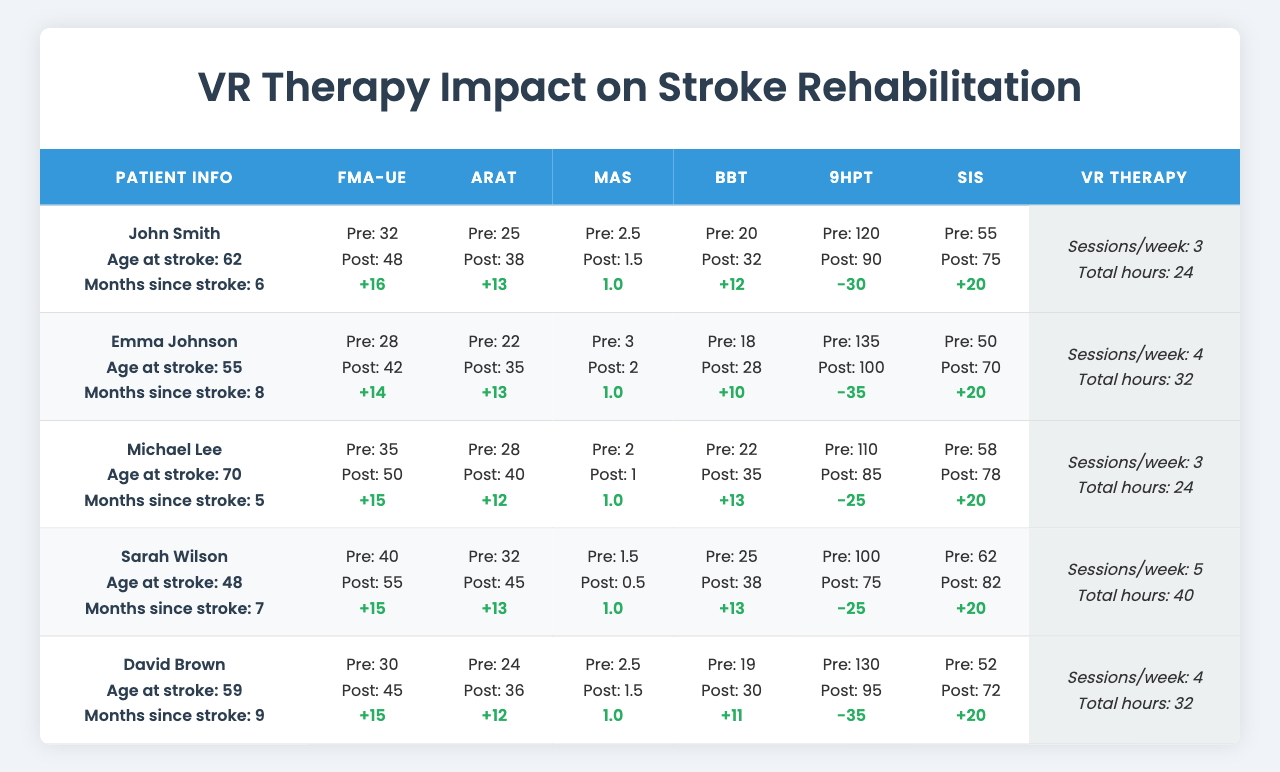What was John Smith's preVR FMA-UE score? In the table, John Smith's preVR FMA-UE score is listed as 32.
Answer: 32 What is the improvement in Sarah Wilson's postVR ARAT score compared to her preVR score? Sarah Wilson's preVR ARAT score is 32 and her postVR ARAT score is 45. The improvement is calculated as 45 - 32 = 13.
Answer: 13 Did David Brown have an increase in his FMA-UE score after the VR therapy? David Brown's preVR FMA-UE score is 30, and his postVR score is 45. Since 45 is greater than 30, there is indeed an increase.
Answer: Yes What was the average postVR MAS score across all patients? The postVR MAS scores are 1.5, 2, 1, 0.5, and 1.5. The average is calculated as (1.5 + 2 + 1 + 0.5 + 1.5) / 5 = 1.5.
Answer: 1.5 Which patient had the highest postVR BBT score, and what was that score? The postVR BBT scores are 32, 28, 35, 38, and 30. The highest score is 38, which is Sarah Wilson's postVR BBT score.
Answer: Sarah Wilson, 38 What was the total improvement in SIS scores for all patients after the VR therapy? The postVR SIS scores are 75, 70, 78, 82, and 72 while the preVR scores are 55, 50, 58, 62, and 52. The total improvement is (75-55) + (70-50) + (78-58) + (82-62) + (72-52) = 20 + 20 + 20 + 20 + 20 = 100.
Answer: 100 Which patient had the lowest score in the 9HPT after VR therapy, and what was that score? The postVR 9HPT scores are 90, 100, 85, 75, and 95. The lowest score is 75, which belongs to Sarah Wilson.
Answer: Sarah Wilson, 75 Is there a correlation between the number of VR sessions per week and the improvement in postVR FMA-UE scores? To assess the correlation, we look at the improvements in postVR FMA-UE scores (16, 14, 15, 15, and 15) and the number of sessions per week (3, 4, 3, 5, and 4). While not a strict correlation, more sessions can be associated with some improvements, but we cannot determine a direct cause without further analysis.
Answer: No definitive correlation How much did Michael Lee's postVR 9HPT score improve compared to his preVR score? Michael Lee's preVR 9HPT score is 110 and his postVR score is 85. The change is calculated as 110 - 85 = 25, indicating a decrease in performance.
Answer: 25 decrease What percentage of the patients showed an improvement in the 9HPT score after VR therapy? Only one patient showed an improvement in their 9HPT score (John Smith). Since there are 5 patients, the percentage is (1/5) * 100 = 20%.
Answer: 20% 